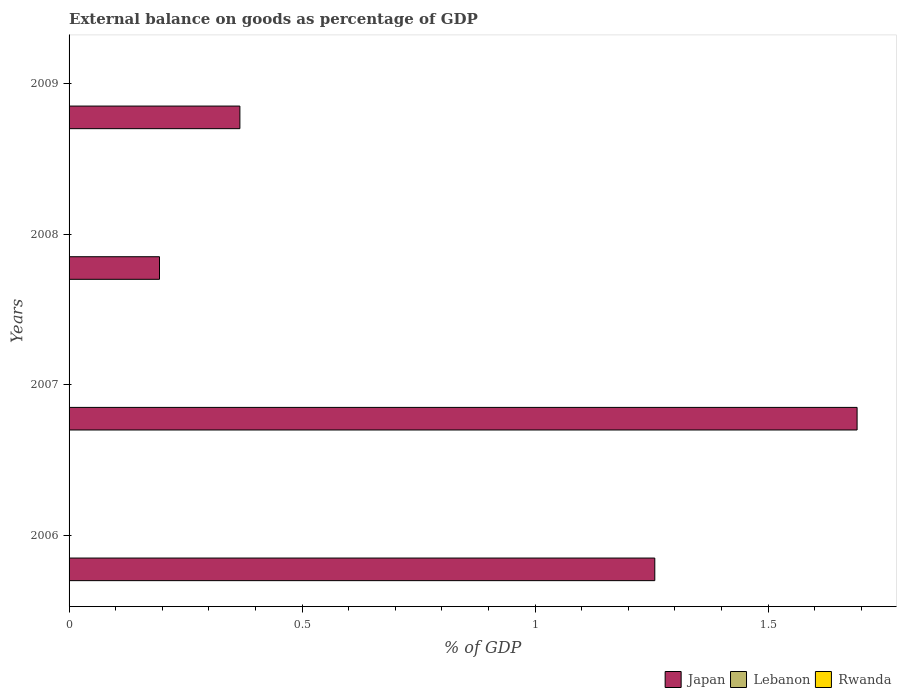Are the number of bars per tick equal to the number of legend labels?
Your answer should be compact. No. Are the number of bars on each tick of the Y-axis equal?
Ensure brevity in your answer.  Yes. How many bars are there on the 1st tick from the bottom?
Offer a very short reply. 1. In how many cases, is the number of bars for a given year not equal to the number of legend labels?
Your response must be concise. 4. What is the total external balance on goods as percentage of GDP in Japan in the graph?
Ensure brevity in your answer.  3.51. What is the difference between the external balance on goods as percentage of GDP in Japan in 2006 and that in 2008?
Offer a terse response. 1.06. What is the average external balance on goods as percentage of GDP in Lebanon per year?
Your answer should be compact. 0. In how many years, is the external balance on goods as percentage of GDP in Lebanon greater than 0.4 %?
Your answer should be very brief. 0. What is the ratio of the external balance on goods as percentage of GDP in Japan in 2006 to that in 2007?
Provide a succinct answer. 0.74. What is the difference between the highest and the second highest external balance on goods as percentage of GDP in Japan?
Your answer should be compact. 0.43. In how many years, is the external balance on goods as percentage of GDP in Lebanon greater than the average external balance on goods as percentage of GDP in Lebanon taken over all years?
Your answer should be very brief. 0. Is it the case that in every year, the sum of the external balance on goods as percentage of GDP in Rwanda and external balance on goods as percentage of GDP in Lebanon is greater than the external balance on goods as percentage of GDP in Japan?
Provide a short and direct response. No. How many bars are there?
Your answer should be very brief. 4. Are all the bars in the graph horizontal?
Offer a very short reply. Yes. What is the difference between two consecutive major ticks on the X-axis?
Your answer should be compact. 0.5. Are the values on the major ticks of X-axis written in scientific E-notation?
Offer a terse response. No. Does the graph contain grids?
Make the answer very short. No. What is the title of the graph?
Keep it short and to the point. External balance on goods as percentage of GDP. What is the label or title of the X-axis?
Your answer should be very brief. % of GDP. What is the label or title of the Y-axis?
Your answer should be compact. Years. What is the % of GDP of Japan in 2006?
Your response must be concise. 1.26. What is the % of GDP in Lebanon in 2006?
Your answer should be very brief. 0. What is the % of GDP of Rwanda in 2006?
Provide a succinct answer. 0. What is the % of GDP in Japan in 2007?
Your answer should be compact. 1.69. What is the % of GDP of Lebanon in 2007?
Make the answer very short. 0. What is the % of GDP of Rwanda in 2007?
Offer a terse response. 0. What is the % of GDP in Japan in 2008?
Offer a terse response. 0.19. What is the % of GDP in Rwanda in 2008?
Provide a short and direct response. 0. What is the % of GDP of Japan in 2009?
Offer a terse response. 0.37. What is the % of GDP of Lebanon in 2009?
Make the answer very short. 0. What is the % of GDP in Rwanda in 2009?
Your answer should be very brief. 0. Across all years, what is the maximum % of GDP of Japan?
Ensure brevity in your answer.  1.69. Across all years, what is the minimum % of GDP in Japan?
Your response must be concise. 0.19. What is the total % of GDP in Japan in the graph?
Your response must be concise. 3.51. What is the total % of GDP in Lebanon in the graph?
Provide a succinct answer. 0. What is the total % of GDP of Rwanda in the graph?
Your response must be concise. 0. What is the difference between the % of GDP in Japan in 2006 and that in 2007?
Give a very brief answer. -0.43. What is the difference between the % of GDP of Japan in 2006 and that in 2008?
Provide a succinct answer. 1.06. What is the difference between the % of GDP in Japan in 2006 and that in 2009?
Give a very brief answer. 0.89. What is the difference between the % of GDP of Japan in 2007 and that in 2008?
Provide a short and direct response. 1.5. What is the difference between the % of GDP of Japan in 2007 and that in 2009?
Provide a succinct answer. 1.32. What is the difference between the % of GDP in Japan in 2008 and that in 2009?
Provide a short and direct response. -0.17. What is the average % of GDP of Japan per year?
Provide a short and direct response. 0.88. What is the ratio of the % of GDP of Japan in 2006 to that in 2007?
Provide a short and direct response. 0.74. What is the ratio of the % of GDP of Japan in 2006 to that in 2008?
Provide a short and direct response. 6.48. What is the ratio of the % of GDP of Japan in 2006 to that in 2009?
Give a very brief answer. 3.43. What is the ratio of the % of GDP in Japan in 2007 to that in 2008?
Your answer should be compact. 8.71. What is the ratio of the % of GDP in Japan in 2007 to that in 2009?
Make the answer very short. 4.61. What is the ratio of the % of GDP in Japan in 2008 to that in 2009?
Your response must be concise. 0.53. What is the difference between the highest and the second highest % of GDP of Japan?
Keep it short and to the point. 0.43. What is the difference between the highest and the lowest % of GDP in Japan?
Ensure brevity in your answer.  1.5. 